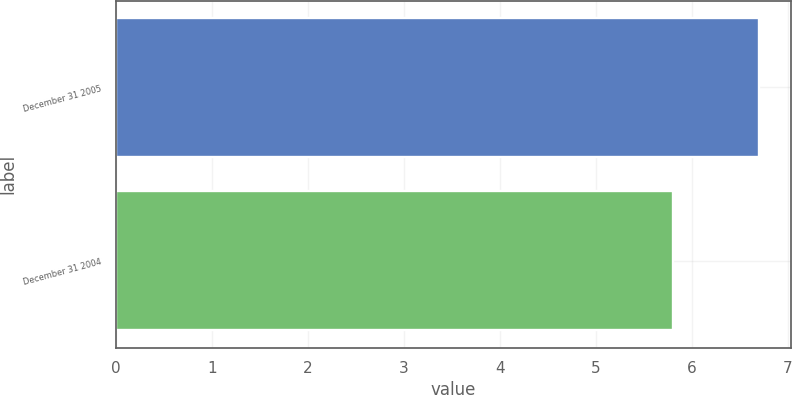Convert chart. <chart><loc_0><loc_0><loc_500><loc_500><bar_chart><fcel>December 31 2005<fcel>December 31 2004<nl><fcel>6.7<fcel>5.8<nl></chart> 